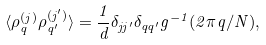Convert formula to latex. <formula><loc_0><loc_0><loc_500><loc_500>\langle \rho ^ { ( j ) } _ { q } \rho ^ { ( j ^ { \prime } ) } _ { q ^ { \prime } } \rangle = \frac { 1 } { d } \delta _ { j j ^ { \prime } } \delta _ { q q ^ { \prime } } g ^ { - 1 } ( 2 \pi q / N ) ,</formula> 